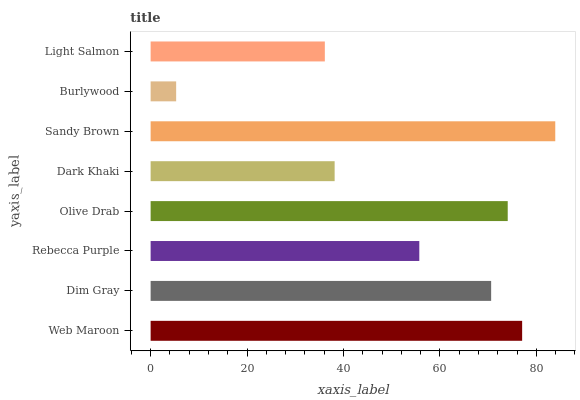Is Burlywood the minimum?
Answer yes or no. Yes. Is Sandy Brown the maximum?
Answer yes or no. Yes. Is Dim Gray the minimum?
Answer yes or no. No. Is Dim Gray the maximum?
Answer yes or no. No. Is Web Maroon greater than Dim Gray?
Answer yes or no. Yes. Is Dim Gray less than Web Maroon?
Answer yes or no. Yes. Is Dim Gray greater than Web Maroon?
Answer yes or no. No. Is Web Maroon less than Dim Gray?
Answer yes or no. No. Is Dim Gray the high median?
Answer yes or no. Yes. Is Rebecca Purple the low median?
Answer yes or no. Yes. Is Olive Drab the high median?
Answer yes or no. No. Is Web Maroon the low median?
Answer yes or no. No. 